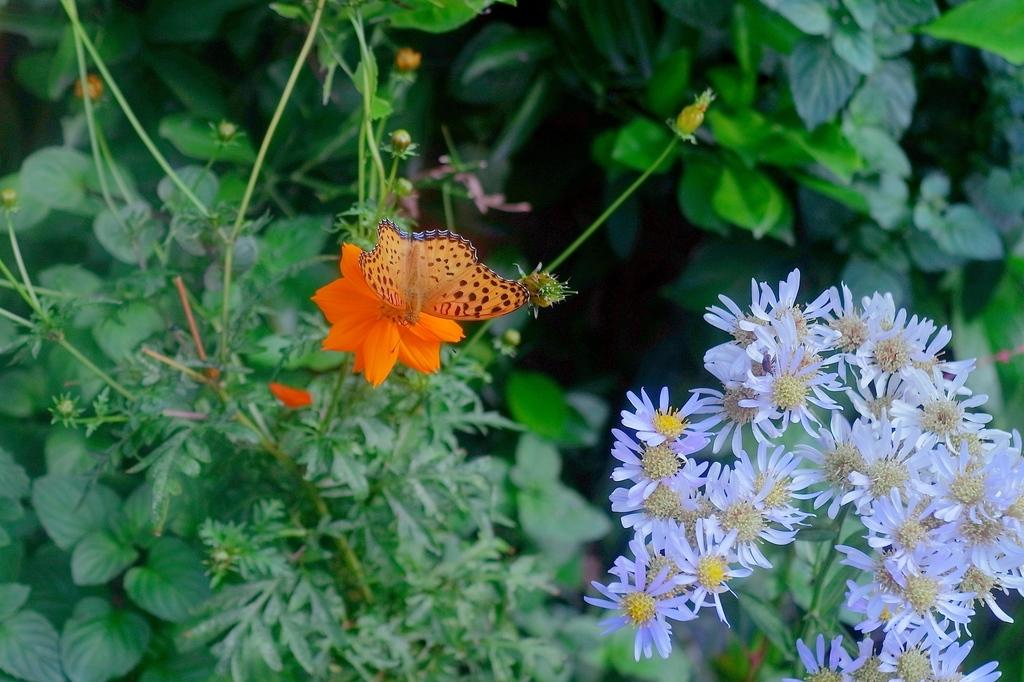What type of plants can be seen in the image? There are flowering plants in the image. What color are the leaves of the plants? There are green leaves in the image. Can you describe any other living organisms present in the image? Yes, there is a flying insect on a flower in the image. What type of lunch is being prepared in the image? There is no indication of any lunch preparation in the image; it features flowering plants, green leaves, and a flying insect on a flower. What attempt is being made by the flowering plants in the image? Flowering plants do not make attempts; they are stationary organisms. 